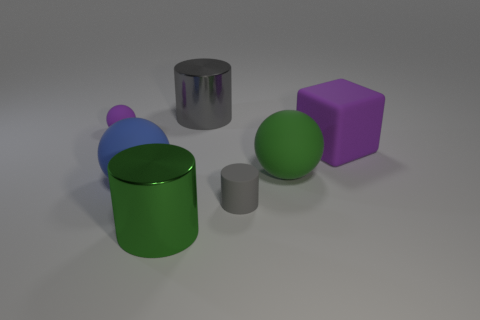Do the block and the rubber sphere right of the tiny rubber cylinder have the same size?
Your answer should be very brief. Yes. There is a purple block behind the large ball to the left of the matte cylinder; what is it made of?
Give a very brief answer. Rubber. Are there the same number of small purple spheres right of the purple ball and purple cubes?
Offer a terse response. No. There is a matte thing that is behind the big green matte thing and to the left of the big green metal object; what size is it?
Your answer should be very brief. Small. What is the color of the large rubber ball on the left side of the green object to the right of the big gray shiny cylinder?
Offer a terse response. Blue. How many brown things are either big shiny cylinders or tiny rubber spheres?
Offer a very short reply. 0. What is the color of the object that is on the right side of the big green shiny cylinder and behind the purple matte block?
Your answer should be very brief. Gray. How many tiny objects are gray metal objects or green spheres?
Give a very brief answer. 0. What size is the other gray matte thing that is the same shape as the large gray object?
Your answer should be compact. Small. The large blue matte thing is what shape?
Provide a succinct answer. Sphere. 